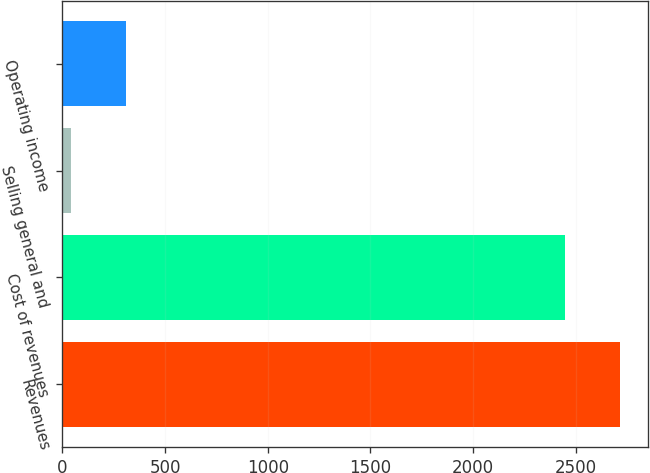Convert chart. <chart><loc_0><loc_0><loc_500><loc_500><bar_chart><fcel>Revenues<fcel>Cost of revenues<fcel>Selling general and<fcel>Operating income<nl><fcel>2714<fcel>2447<fcel>42<fcel>309<nl></chart> 